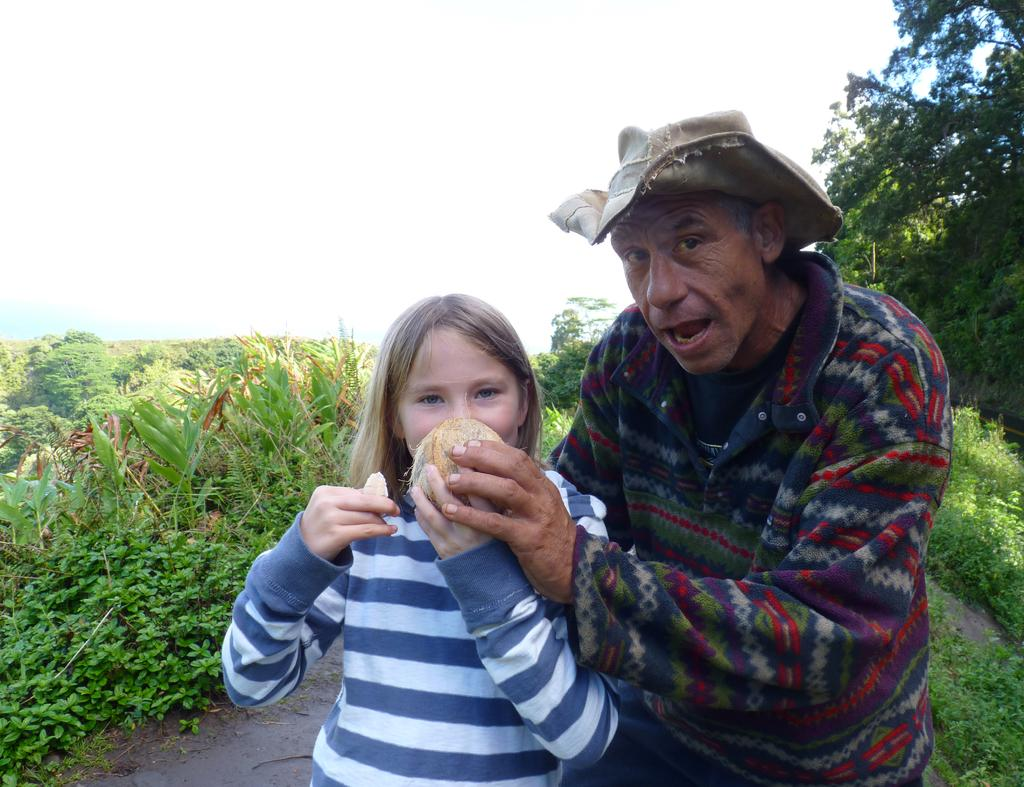How many people are in the image? There are two people in the image. What are the people doing in the image? The people are standing and holding fruit. What can be seen in the background of the image? There are trees and plants in the background of the image. What is visible at the top of the image? The sky is visible at the top of the image. What is visible at the bottom of the image? The ground is visible at the bottom of the image. What type of tail can be seen on the page in the image? There is no page or tail present in the image. What is the roof made of in the image? There is no roof present in the image. 